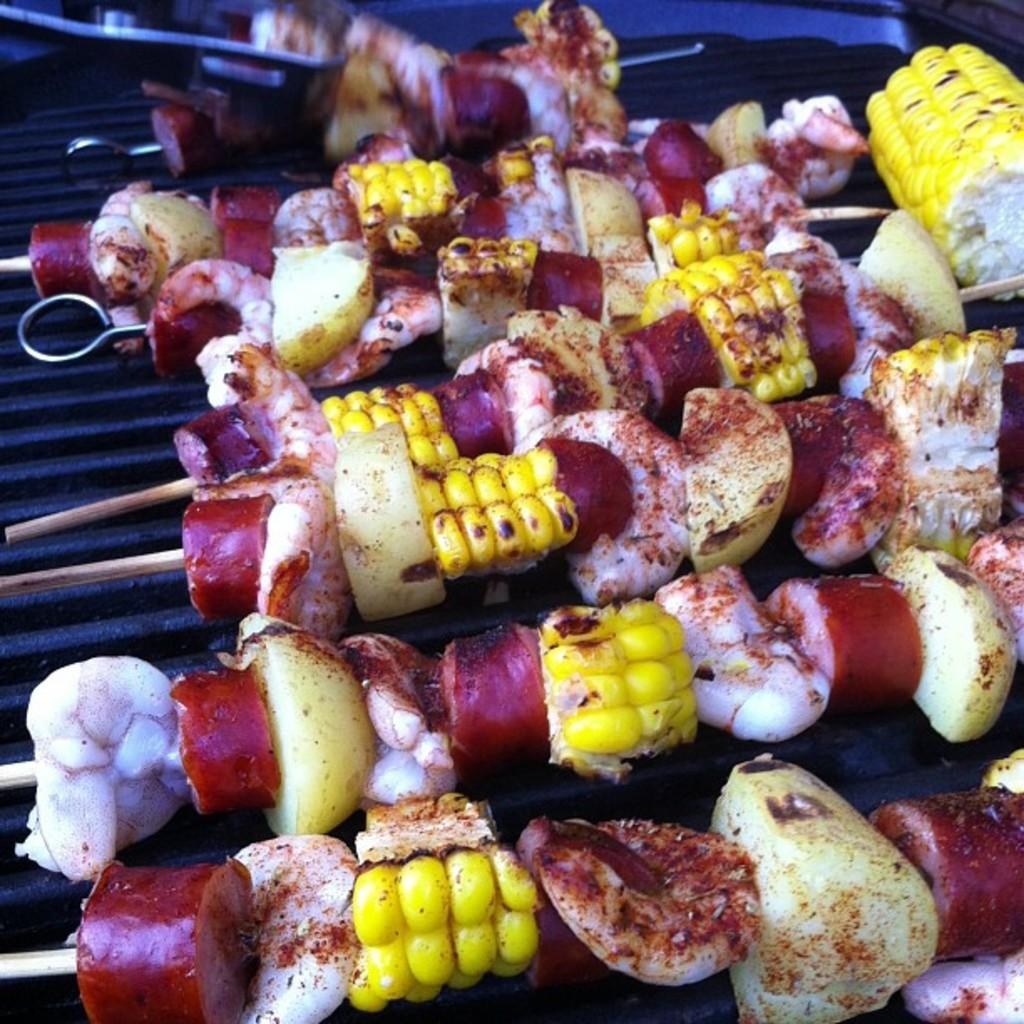What type of food is being cooked on the grill in the image? There is meat and corn on the grill. Are there any other items being cooked on the grill? Yes, there are other items on the grill. Can you describe the other items on the grill? Unfortunately, the facts provided do not specify what the other items are. What type of wool is being used to make a spring in the image? There is no wool or spring present in the image; it features a grill with meat, corn, and other items. 